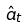Convert formula to latex. <formula><loc_0><loc_0><loc_500><loc_500>\hat { a } _ { t }</formula> 